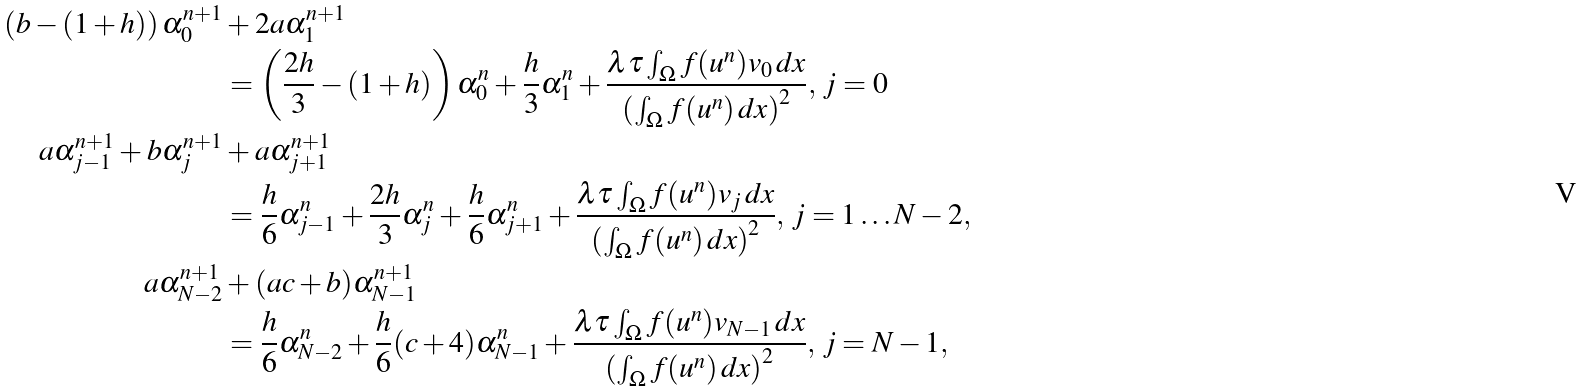Convert formula to latex. <formula><loc_0><loc_0><loc_500><loc_500>\left ( b - ( 1 + h ) \right ) \alpha _ { 0 } ^ { n + 1 } & + 2 a \alpha _ { 1 } ^ { n + 1 } \\ & = \left ( \frac { 2 h } { 3 } - ( 1 + h ) \right ) \alpha _ { 0 } ^ { n } + \frac { h } { 3 } \alpha _ { 1 } ^ { n } + \frac { \lambda \tau \int _ { \Omega } f ( u ^ { n } ) v _ { 0 } \, d x } { \left ( \int _ { \Omega } f ( u ^ { n } ) \, d x \right ) ^ { 2 } } , \, j = 0 \\ a \alpha _ { j - 1 } ^ { n + 1 } + b \alpha _ { j } ^ { n + 1 } & + a \alpha _ { j + 1 } ^ { n + 1 } \\ & = \frac { h } { 6 } \alpha _ { j - 1 } ^ { n } + \frac { 2 h } { 3 } \alpha _ { j } ^ { n } + \frac { h } { 6 } \alpha _ { j + 1 } ^ { n } + \frac { \lambda \tau \int _ { \Omega } f ( u ^ { n } ) v _ { j } \, d x } { \left ( \int _ { \Omega } f ( u ^ { n } ) \, d x \right ) ^ { 2 } } , \, j = 1 \dots N - 2 , \\ a \alpha _ { N - 2 } ^ { n + 1 } & + ( a c + b ) \alpha _ { N - 1 } ^ { n + 1 } \\ & = \frac { h } { 6 } \alpha _ { N - 2 } ^ { n } + \frac { h } { 6 } ( c + 4 ) \alpha _ { N - 1 } ^ { n } + \frac { \lambda \tau \int _ { \Omega } f ( u ^ { n } ) v _ { N - 1 } \, d x } { \left ( \int _ { \Omega } f ( u ^ { n } ) \, d x \right ) ^ { 2 } } , \, j = N - 1 ,</formula> 